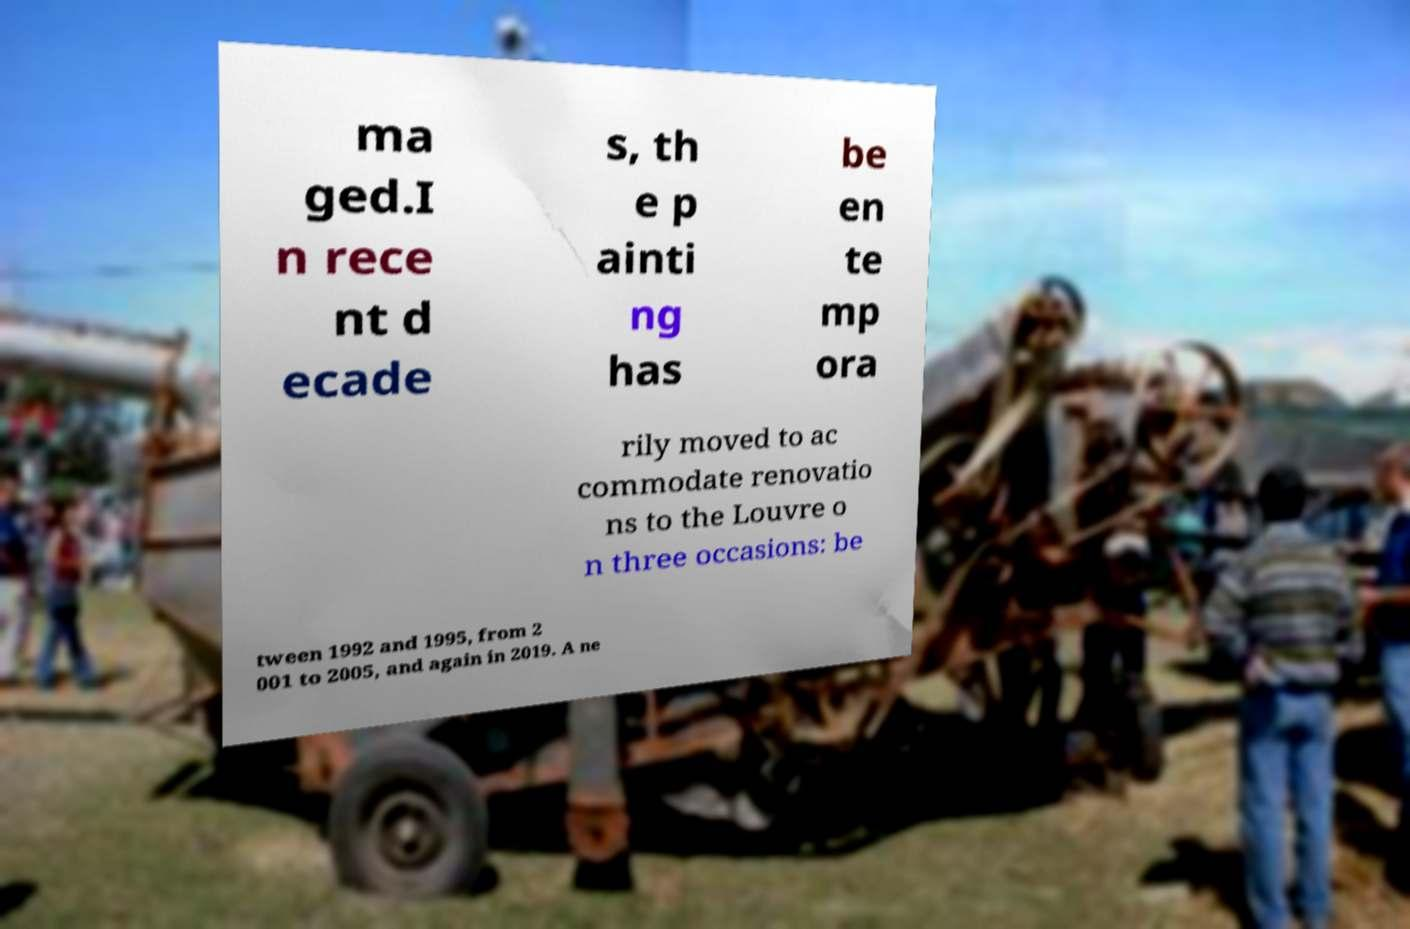Could you assist in decoding the text presented in this image and type it out clearly? ma ged.I n rece nt d ecade s, th e p ainti ng has be en te mp ora rily moved to ac commodate renovatio ns to the Louvre o n three occasions: be tween 1992 and 1995, from 2 001 to 2005, and again in 2019. A ne 